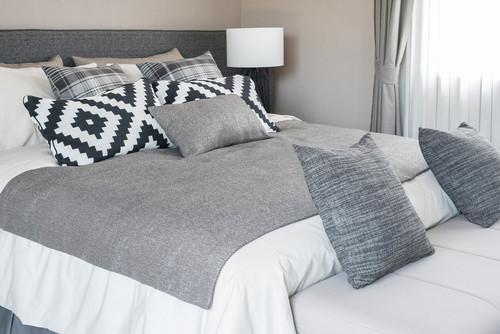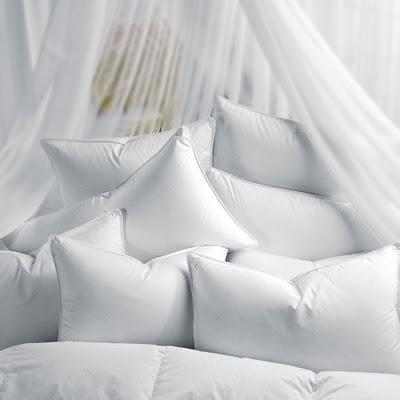The first image is the image on the left, the second image is the image on the right. For the images shown, is this caption "All bedding and pillows in one image are white." true? Answer yes or no. Yes. The first image is the image on the left, the second image is the image on the right. Considering the images on both sides, is "there is exactly one lamp in one of the images." valid? Answer yes or no. Yes. 